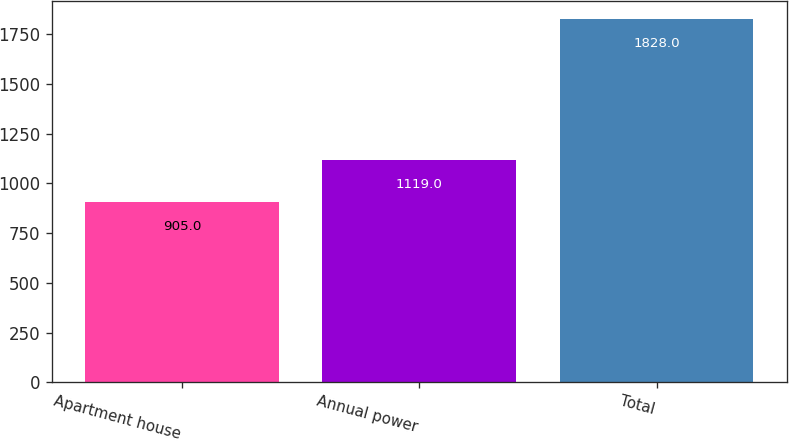Convert chart to OTSL. <chart><loc_0><loc_0><loc_500><loc_500><bar_chart><fcel>Apartment house<fcel>Annual power<fcel>Total<nl><fcel>905<fcel>1119<fcel>1828<nl></chart> 